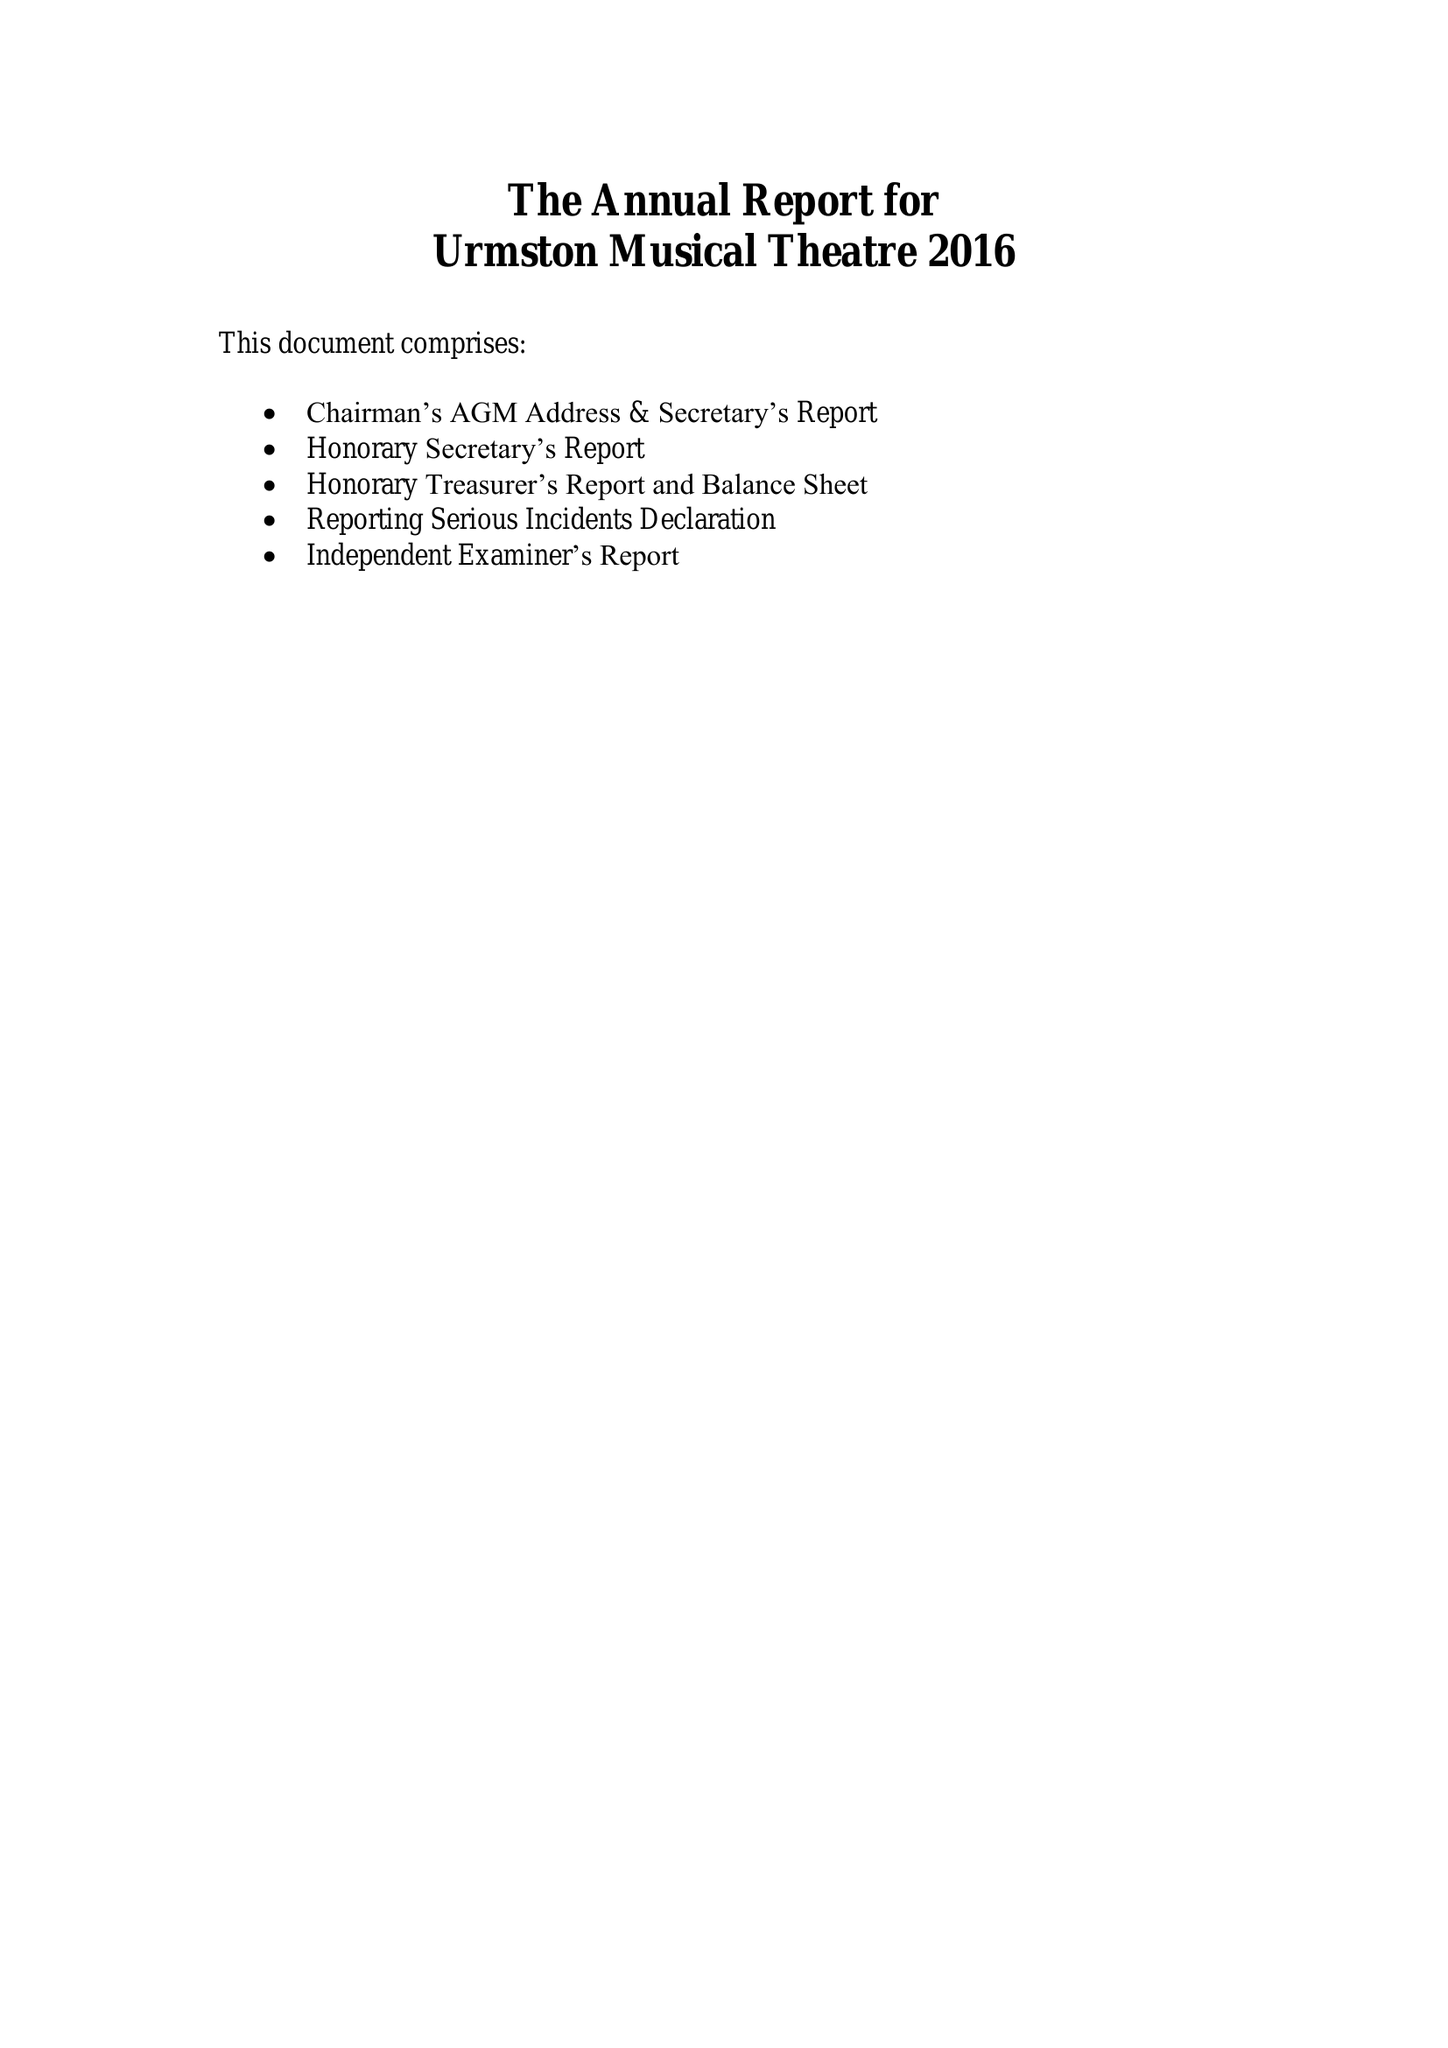What is the value for the spending_annually_in_british_pounds?
Answer the question using a single word or phrase. 33099.00 